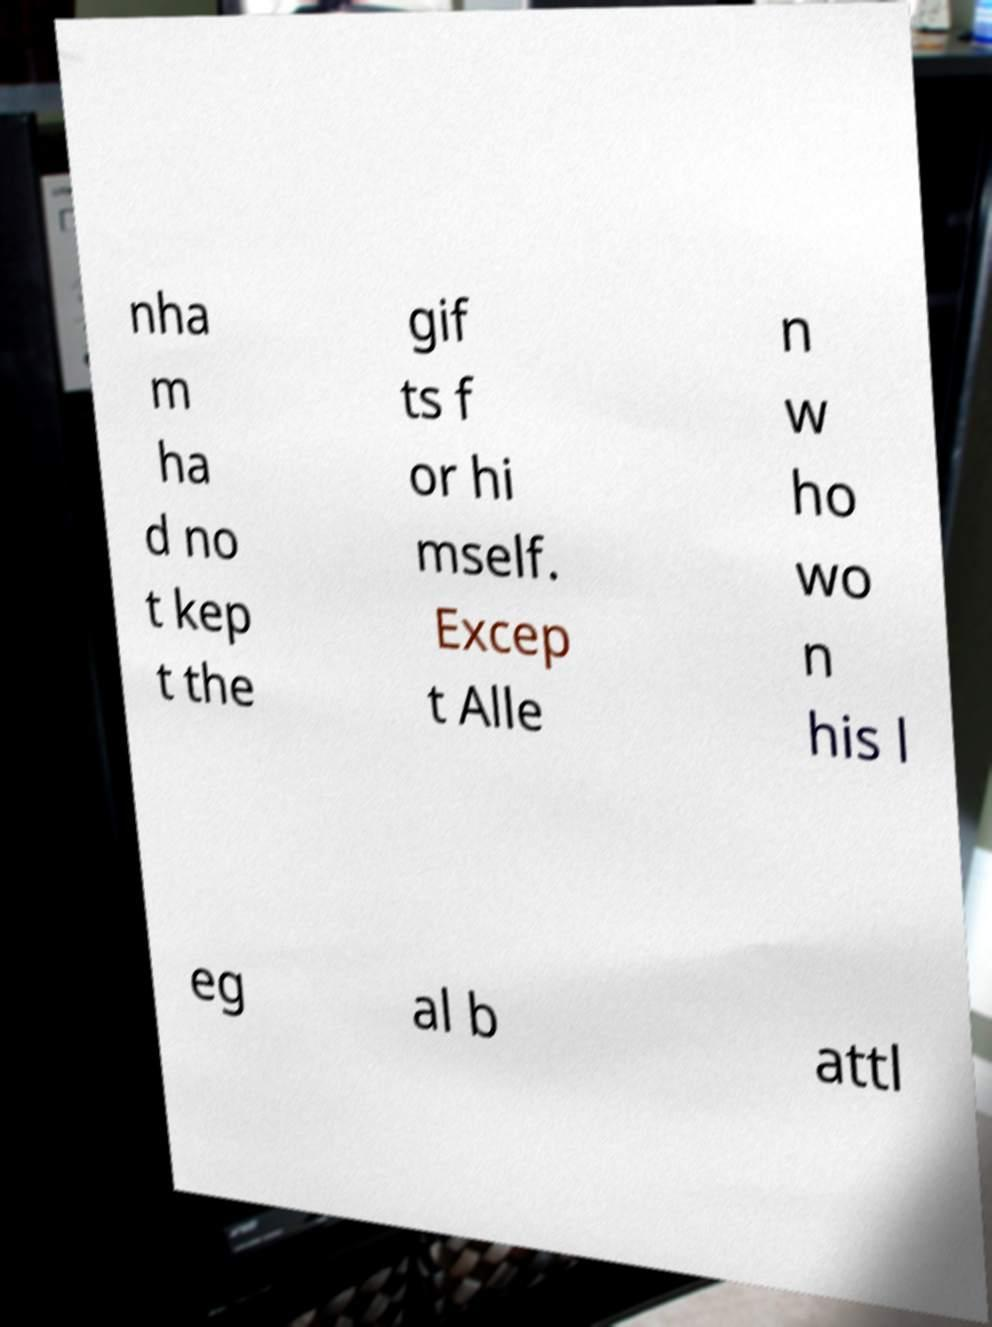Please identify and transcribe the text found in this image. nha m ha d no t kep t the gif ts f or hi mself. Excep t Alle n w ho wo n his l eg al b attl 